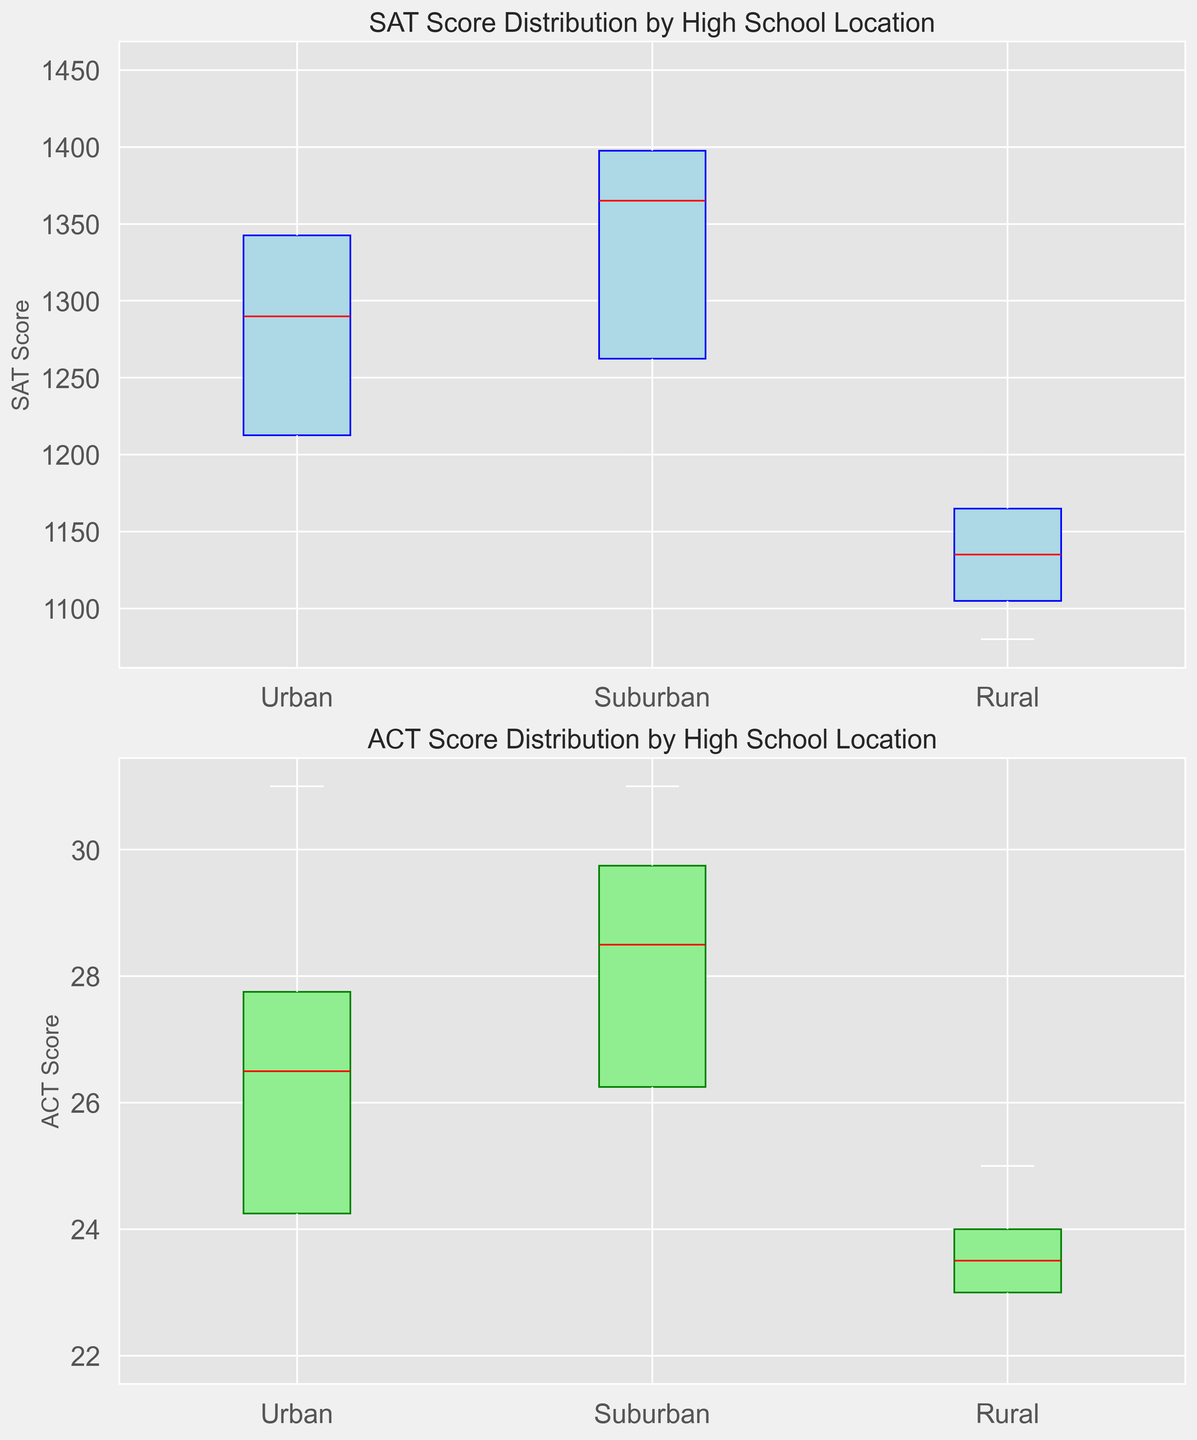Which high school location has the highest median SAT score? To find the median SAT score for each location, look at the horizontal line inside each box in the top plot. The suburban location has the highest median SAT score among the three.
Answer: Suburban Which location shows the least spread in SAT scores? Observe the length of the boxes and whiskers in the top box plot for each location. The urban location has the shortest overall length, indicating the least spread in SAT scores.
Answer: Urban How does the range of ACT scores in rural schools compare to urban schools? Evaluate the distance from the bottom whisker to the top whisker to find the range for ACT scores in each location. The range for rural schools (22 to 25) is smaller than that for urban schools (22 to 31), indicating less variability in rural ACT scores.
Answer: Smaller What is the difference between the median SAT scores of suburban and rural schools? Identify the horizontal lines inside the boxes for suburban and rural schools on the SAT box plot. For suburban, the median is around 1380, and for rural, it is around 1140. The difference is 1380 - 1140 = 240.
Answer: 240 Which location has the lowest median ACT score? Look at the median lines inside the boxes in the bottom plot. The urban location's median is the lowest, indicated by a horizontal line at 25.
Answer: Urban Is the median ACT score higher in suburban schools compared to rural schools? Compare the median lines in the bottom box plot. The median ACT score for suburban schools is higher than that for rural schools.
Answer: Yes Which location's SAT scores have the widest interquartile range (IQR)? The interquartile range is represented by the length of the box (from the lower to upper quartile). The suburban location has the widest box, indicating the widest IQR.
Answer: Suburban Are the SAT scores in suburban schools generally higher than those in urban schools? Compare the boxes' positions and their medians in the SAT box plot. The suburban box is shifted upwards compared to the urban box, indicating higher SAT scores overall.
Answer: Yes What can be observed about the outliers in the ACT score distribution? Check for any marks outside the whiskers in the bottom plot. There are no obvious outliers in the ACT score distributions for any of the locations.
Answer: No Which group has more similar SAT and ACT score distributions? Compare the location of the boxes and median lines in both plots for each location type. Urban SAT and ACT scores have more similar distributions as their ranges and median lines closely align.
Answer: Urban 